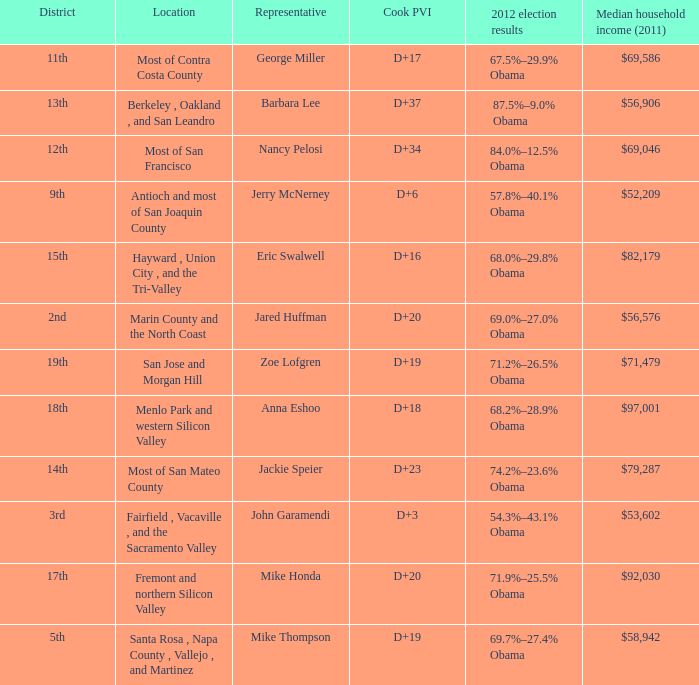How many locations have a median household income in 2011 of $71,479? 1.0. 